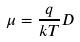<formula> <loc_0><loc_0><loc_500><loc_500>\mu = \frac { q } { k T } D</formula> 